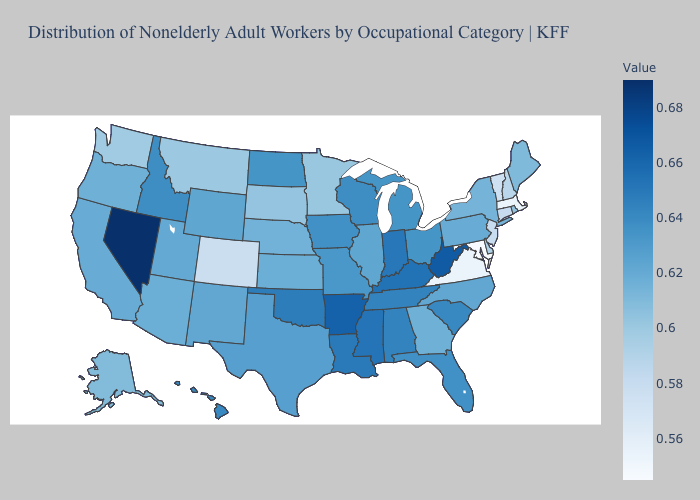Does Massachusetts have the lowest value in the Northeast?
Keep it brief. Yes. Does Texas have a lower value than Washington?
Short answer required. No. Does Maryland have the lowest value in the USA?
Answer briefly. Yes. Among the states that border Rhode Island , which have the highest value?
Write a very short answer. Connecticut. Does the map have missing data?
Short answer required. No. Does Nevada have the highest value in the USA?
Concise answer only. Yes. 